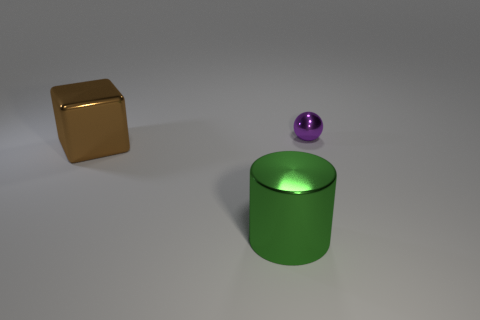Is the number of small metal things on the right side of the metallic cylinder greater than the number of big brown metal things that are in front of the brown block?
Your response must be concise. Yes. Are there any shiny balls that are on the right side of the thing that is left of the large metallic thing that is on the right side of the large brown metal object?
Give a very brief answer. Yes. Is the number of purple objects behind the brown cube less than the number of small shiny things that are to the right of the small purple metallic thing?
Your answer should be compact. No. What material is the purple sphere?
Offer a very short reply. Metal. What number of large shiny objects are in front of the brown metallic block?
Your answer should be very brief. 1. Are there fewer large green shiny things on the right side of the cylinder than gray blocks?
Give a very brief answer. No. The small metal object is what color?
Provide a short and direct response. Purple. What number of large things are red shiny cylinders or green things?
Your response must be concise. 1. There is a thing behind the big cube; what size is it?
Give a very brief answer. Small. Are there any other large blocks that have the same color as the large metal cube?
Your answer should be very brief. No. 